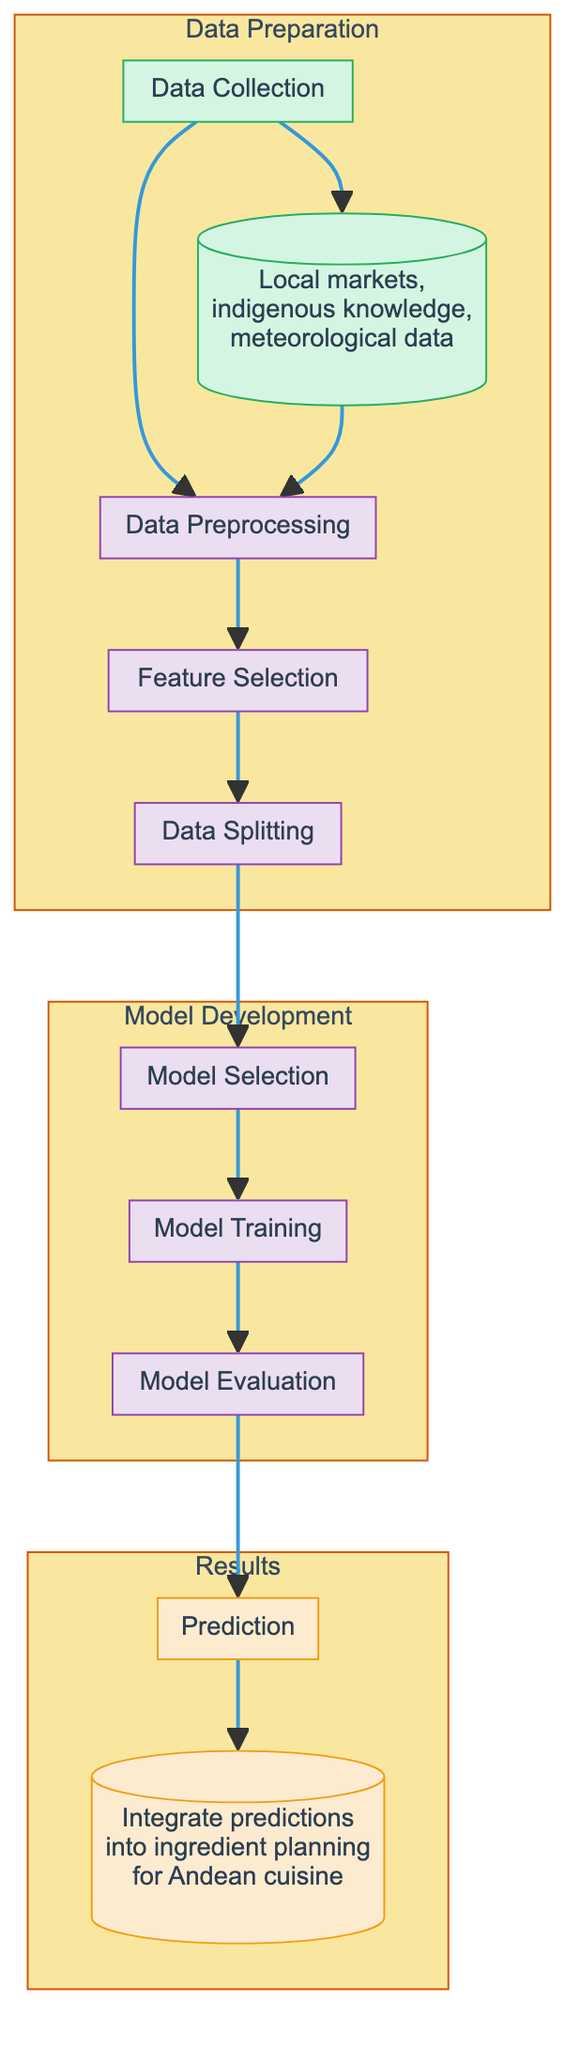What are the data sources mentioned in the diagram? The diagram specifies three data sources: local markets, indigenous knowledge, and meteorological data, which are all connected to the data collection process.
Answer: Local markets, indigenous knowledge, meteorological data How many main processes are involved in the machine learning pipeline? In the diagram, there are four main process sections: Data Preparation, Model Development, and Results, making a total of three distinct sections where processes occur.
Answer: Three What is the last step before the application of predictions? The prediction node is directly linked to the application node, indicating that prediction is the final step before integrating into ingredient planning for Andean cuisine.
Answer: Prediction Which node follows data splitting in the workflow? According to the diagram, the node that follows data splitting is model selection, which means it is part of the flow of the data processing steps.
Answer: Model Selection What is the output of the entire process as given in the diagram? The final output is specified in the application node, which describes the integration of predictions for ingredient planning into Andean cuisine.
Answer: Integrate predictions into ingredient planning for Andean cuisine What does the feature selection process aim to achieve? Feature selection is a critical process in the model development stage, aiming to identify the most relevant input variables for improving model performance and accuracy.
Answer: Identify relevant input variables 